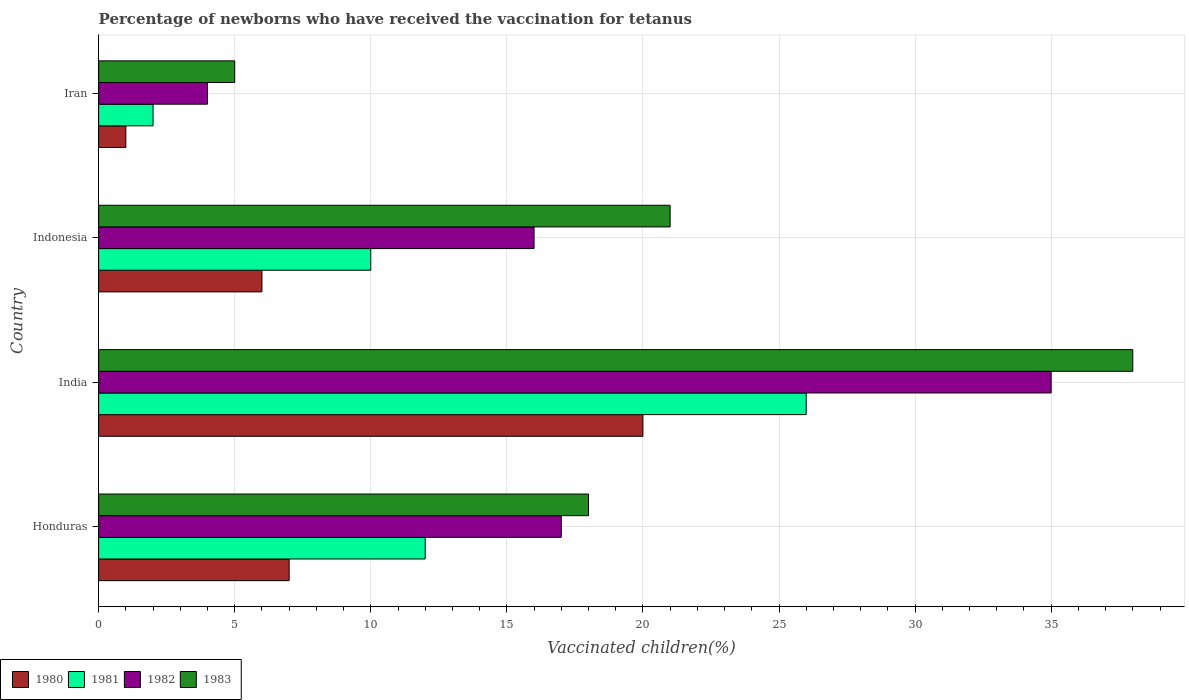How many different coloured bars are there?
Make the answer very short. 4. How many groups of bars are there?
Your answer should be very brief. 4. Are the number of bars per tick equal to the number of legend labels?
Provide a succinct answer. Yes. Are the number of bars on each tick of the Y-axis equal?
Make the answer very short. Yes. In how many cases, is the number of bars for a given country not equal to the number of legend labels?
Provide a succinct answer. 0. In which country was the percentage of vaccinated children in 1980 maximum?
Provide a short and direct response. India. In which country was the percentage of vaccinated children in 1980 minimum?
Your response must be concise. Iran. What is the total percentage of vaccinated children in 1980 in the graph?
Keep it short and to the point. 34. What is the difference between the percentage of vaccinated children in 1983 in India and that in Indonesia?
Provide a succinct answer. 17. What is the difference between the percentage of vaccinated children in 1980 in India and the percentage of vaccinated children in 1982 in Honduras?
Provide a short and direct response. 3. What is the average percentage of vaccinated children in 1980 per country?
Offer a terse response. 8.5. In how many countries, is the percentage of vaccinated children in 1981 greater than 25 %?
Ensure brevity in your answer.  1. Is the percentage of vaccinated children in 1982 in India less than that in Indonesia?
Keep it short and to the point. No. What is the difference between the highest and the second highest percentage of vaccinated children in 1981?
Your answer should be compact. 14. What is the difference between the highest and the lowest percentage of vaccinated children in 1983?
Offer a terse response. 33. Is the sum of the percentage of vaccinated children in 1983 in Indonesia and Iran greater than the maximum percentage of vaccinated children in 1982 across all countries?
Offer a terse response. No. What does the 4th bar from the bottom in India represents?
Give a very brief answer. 1983. How many bars are there?
Your answer should be compact. 16. Are all the bars in the graph horizontal?
Provide a short and direct response. Yes. What is the difference between two consecutive major ticks on the X-axis?
Provide a succinct answer. 5. Are the values on the major ticks of X-axis written in scientific E-notation?
Provide a short and direct response. No. Does the graph contain grids?
Your answer should be very brief. Yes. How are the legend labels stacked?
Ensure brevity in your answer.  Horizontal. What is the title of the graph?
Your response must be concise. Percentage of newborns who have received the vaccination for tetanus. Does "1977" appear as one of the legend labels in the graph?
Offer a terse response. No. What is the label or title of the X-axis?
Make the answer very short. Vaccinated children(%). What is the Vaccinated children(%) of 1980 in Honduras?
Keep it short and to the point. 7. What is the Vaccinated children(%) of 1981 in Honduras?
Your response must be concise. 12. What is the Vaccinated children(%) in 1983 in Honduras?
Your answer should be very brief. 18. What is the Vaccinated children(%) in 1981 in India?
Give a very brief answer. 26. What is the Vaccinated children(%) in 1982 in India?
Give a very brief answer. 35. What is the Vaccinated children(%) in 1983 in India?
Your response must be concise. 38. What is the Vaccinated children(%) of 1983 in Indonesia?
Your answer should be compact. 21. What is the Vaccinated children(%) of 1980 in Iran?
Your answer should be very brief. 1. What is the Vaccinated children(%) in 1981 in Iran?
Give a very brief answer. 2. Across all countries, what is the maximum Vaccinated children(%) of 1983?
Make the answer very short. 38. Across all countries, what is the minimum Vaccinated children(%) of 1980?
Ensure brevity in your answer.  1. Across all countries, what is the minimum Vaccinated children(%) of 1981?
Your answer should be very brief. 2. Across all countries, what is the minimum Vaccinated children(%) in 1982?
Make the answer very short. 4. Across all countries, what is the minimum Vaccinated children(%) in 1983?
Your answer should be compact. 5. What is the difference between the Vaccinated children(%) in 1982 in Honduras and that in Indonesia?
Make the answer very short. 1. What is the difference between the Vaccinated children(%) in 1980 in Honduras and that in Iran?
Keep it short and to the point. 6. What is the difference between the Vaccinated children(%) of 1983 in Honduras and that in Iran?
Offer a terse response. 13. What is the difference between the Vaccinated children(%) of 1980 in India and that in Iran?
Offer a terse response. 19. What is the difference between the Vaccinated children(%) of 1981 in India and that in Iran?
Make the answer very short. 24. What is the difference between the Vaccinated children(%) in 1981 in Indonesia and that in Iran?
Provide a short and direct response. 8. What is the difference between the Vaccinated children(%) of 1980 in Honduras and the Vaccinated children(%) of 1983 in India?
Ensure brevity in your answer.  -31. What is the difference between the Vaccinated children(%) in 1981 in Honduras and the Vaccinated children(%) in 1982 in India?
Your answer should be compact. -23. What is the difference between the Vaccinated children(%) of 1981 in Honduras and the Vaccinated children(%) of 1983 in India?
Ensure brevity in your answer.  -26. What is the difference between the Vaccinated children(%) in 1980 in Honduras and the Vaccinated children(%) in 1982 in Indonesia?
Provide a short and direct response. -9. What is the difference between the Vaccinated children(%) of 1980 in Honduras and the Vaccinated children(%) of 1981 in Iran?
Provide a short and direct response. 5. What is the difference between the Vaccinated children(%) in 1980 in Honduras and the Vaccinated children(%) in 1982 in Iran?
Give a very brief answer. 3. What is the difference between the Vaccinated children(%) in 1980 in Honduras and the Vaccinated children(%) in 1983 in Iran?
Offer a terse response. 2. What is the difference between the Vaccinated children(%) of 1981 in Honduras and the Vaccinated children(%) of 1982 in Iran?
Your response must be concise. 8. What is the difference between the Vaccinated children(%) of 1981 in Honduras and the Vaccinated children(%) of 1983 in Iran?
Your answer should be very brief. 7. What is the difference between the Vaccinated children(%) in 1980 in India and the Vaccinated children(%) in 1981 in Indonesia?
Give a very brief answer. 10. What is the difference between the Vaccinated children(%) in 1981 in India and the Vaccinated children(%) in 1982 in Indonesia?
Provide a succinct answer. 10. What is the difference between the Vaccinated children(%) in 1981 in India and the Vaccinated children(%) in 1983 in Indonesia?
Offer a very short reply. 5. What is the difference between the Vaccinated children(%) in 1982 in India and the Vaccinated children(%) in 1983 in Indonesia?
Give a very brief answer. 14. What is the difference between the Vaccinated children(%) in 1980 in India and the Vaccinated children(%) in 1981 in Iran?
Your answer should be compact. 18. What is the difference between the Vaccinated children(%) in 1981 in India and the Vaccinated children(%) in 1983 in Iran?
Offer a terse response. 21. What is the difference between the Vaccinated children(%) of 1982 in India and the Vaccinated children(%) of 1983 in Iran?
Give a very brief answer. 30. What is the difference between the Vaccinated children(%) in 1981 in Indonesia and the Vaccinated children(%) in 1982 in Iran?
Offer a very short reply. 6. What is the difference between the Vaccinated children(%) of 1982 in Indonesia and the Vaccinated children(%) of 1983 in Iran?
Ensure brevity in your answer.  11. What is the average Vaccinated children(%) in 1981 per country?
Provide a succinct answer. 12.5. What is the average Vaccinated children(%) in 1982 per country?
Offer a terse response. 18. What is the difference between the Vaccinated children(%) of 1980 and Vaccinated children(%) of 1983 in Honduras?
Provide a short and direct response. -11. What is the difference between the Vaccinated children(%) in 1981 and Vaccinated children(%) in 1982 in Honduras?
Provide a short and direct response. -5. What is the difference between the Vaccinated children(%) in 1981 and Vaccinated children(%) in 1983 in Honduras?
Make the answer very short. -6. What is the difference between the Vaccinated children(%) in 1982 and Vaccinated children(%) in 1983 in Honduras?
Make the answer very short. -1. What is the difference between the Vaccinated children(%) of 1980 and Vaccinated children(%) of 1981 in India?
Your response must be concise. -6. What is the difference between the Vaccinated children(%) of 1980 and Vaccinated children(%) of 1983 in India?
Provide a short and direct response. -18. What is the difference between the Vaccinated children(%) of 1981 and Vaccinated children(%) of 1983 in India?
Give a very brief answer. -12. What is the difference between the Vaccinated children(%) in 1982 and Vaccinated children(%) in 1983 in India?
Your answer should be very brief. -3. What is the difference between the Vaccinated children(%) in 1980 and Vaccinated children(%) in 1981 in Indonesia?
Make the answer very short. -4. What is the difference between the Vaccinated children(%) of 1980 and Vaccinated children(%) of 1982 in Indonesia?
Offer a terse response. -10. What is the difference between the Vaccinated children(%) in 1980 and Vaccinated children(%) in 1983 in Indonesia?
Ensure brevity in your answer.  -15. What is the difference between the Vaccinated children(%) of 1980 and Vaccinated children(%) of 1983 in Iran?
Offer a very short reply. -4. What is the difference between the Vaccinated children(%) in 1981 and Vaccinated children(%) in 1983 in Iran?
Keep it short and to the point. -3. What is the difference between the Vaccinated children(%) in 1982 and Vaccinated children(%) in 1983 in Iran?
Give a very brief answer. -1. What is the ratio of the Vaccinated children(%) of 1981 in Honduras to that in India?
Your answer should be compact. 0.46. What is the ratio of the Vaccinated children(%) of 1982 in Honduras to that in India?
Your response must be concise. 0.49. What is the ratio of the Vaccinated children(%) of 1983 in Honduras to that in India?
Provide a short and direct response. 0.47. What is the ratio of the Vaccinated children(%) in 1981 in Honduras to that in Indonesia?
Ensure brevity in your answer.  1.2. What is the ratio of the Vaccinated children(%) of 1982 in Honduras to that in Iran?
Offer a terse response. 4.25. What is the ratio of the Vaccinated children(%) in 1983 in Honduras to that in Iran?
Provide a short and direct response. 3.6. What is the ratio of the Vaccinated children(%) in 1980 in India to that in Indonesia?
Your answer should be compact. 3.33. What is the ratio of the Vaccinated children(%) of 1982 in India to that in Indonesia?
Provide a short and direct response. 2.19. What is the ratio of the Vaccinated children(%) in 1983 in India to that in Indonesia?
Make the answer very short. 1.81. What is the ratio of the Vaccinated children(%) of 1982 in India to that in Iran?
Provide a short and direct response. 8.75. What is the ratio of the Vaccinated children(%) in 1980 in Indonesia to that in Iran?
Give a very brief answer. 6. What is the ratio of the Vaccinated children(%) of 1981 in Indonesia to that in Iran?
Your response must be concise. 5. What is the difference between the highest and the second highest Vaccinated children(%) of 1981?
Offer a very short reply. 14. What is the difference between the highest and the lowest Vaccinated children(%) in 1982?
Make the answer very short. 31. 